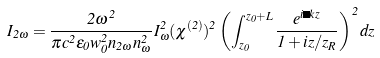Convert formula to latex. <formula><loc_0><loc_0><loc_500><loc_500>I _ { 2 \omega } = { \frac { 2 { \omega } ^ { 2 } } { \pi c ^ { 2 } \epsilon _ { 0 } w _ { 0 } ^ { 2 } n _ { 2 \omega } n _ { \omega } ^ { 2 } } } I _ { \omega } ^ { 2 } ( { \chi } ^ { ( 2 ) } ) ^ { 2 } \left ( \int _ { z _ { 0 } } ^ { z _ { 0 } + L } { \frac { e ^ { i \Delta k z } } { 1 + i z / z _ { R } } } \right ) ^ { 2 } d z</formula> 